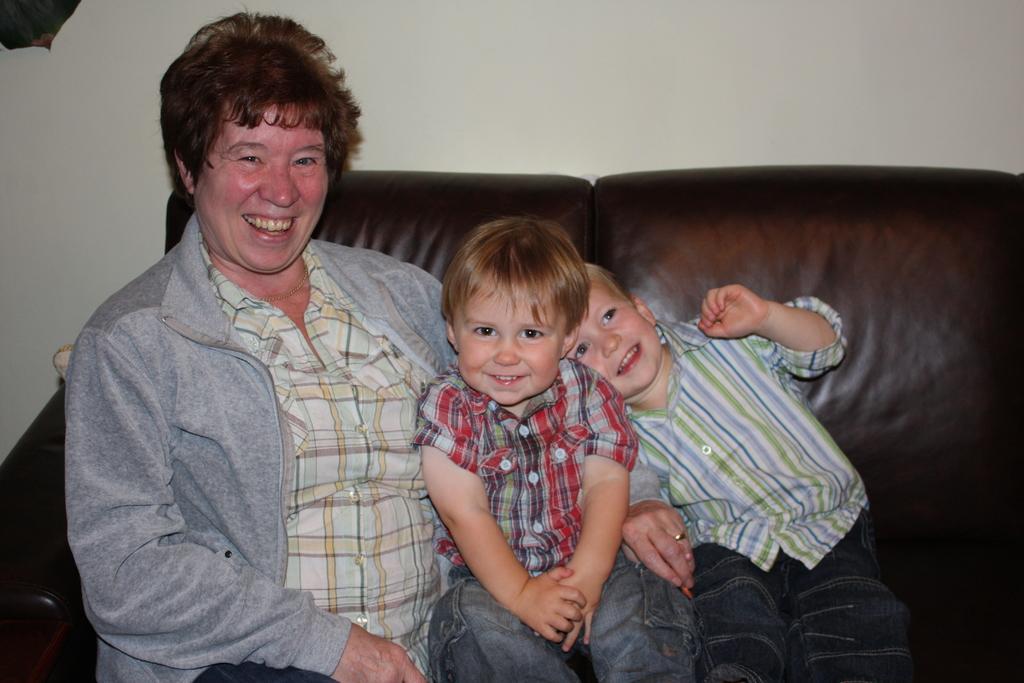Could you give a brief overview of what you see in this image? Here we can see a person and two kids sitting on the sofa and they are smiling. In the background we can see a wall. 